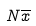Convert formula to latex. <formula><loc_0><loc_0><loc_500><loc_500>N \overline { x }</formula> 